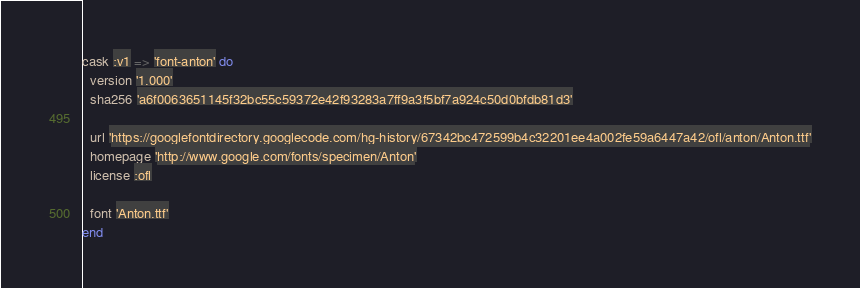<code> <loc_0><loc_0><loc_500><loc_500><_Ruby_>cask :v1 => 'font-anton' do
  version '1.000'
  sha256 'a6f0063651145f32bc55c59372e42f93283a7ff9a3f5bf7a924c50d0bfdb81d3'

  url 'https://googlefontdirectory.googlecode.com/hg-history/67342bc472599b4c32201ee4a002fe59a6447a42/ofl/anton/Anton.ttf'
  homepage 'http://www.google.com/fonts/specimen/Anton'
  license :ofl

  font 'Anton.ttf'
end
</code> 